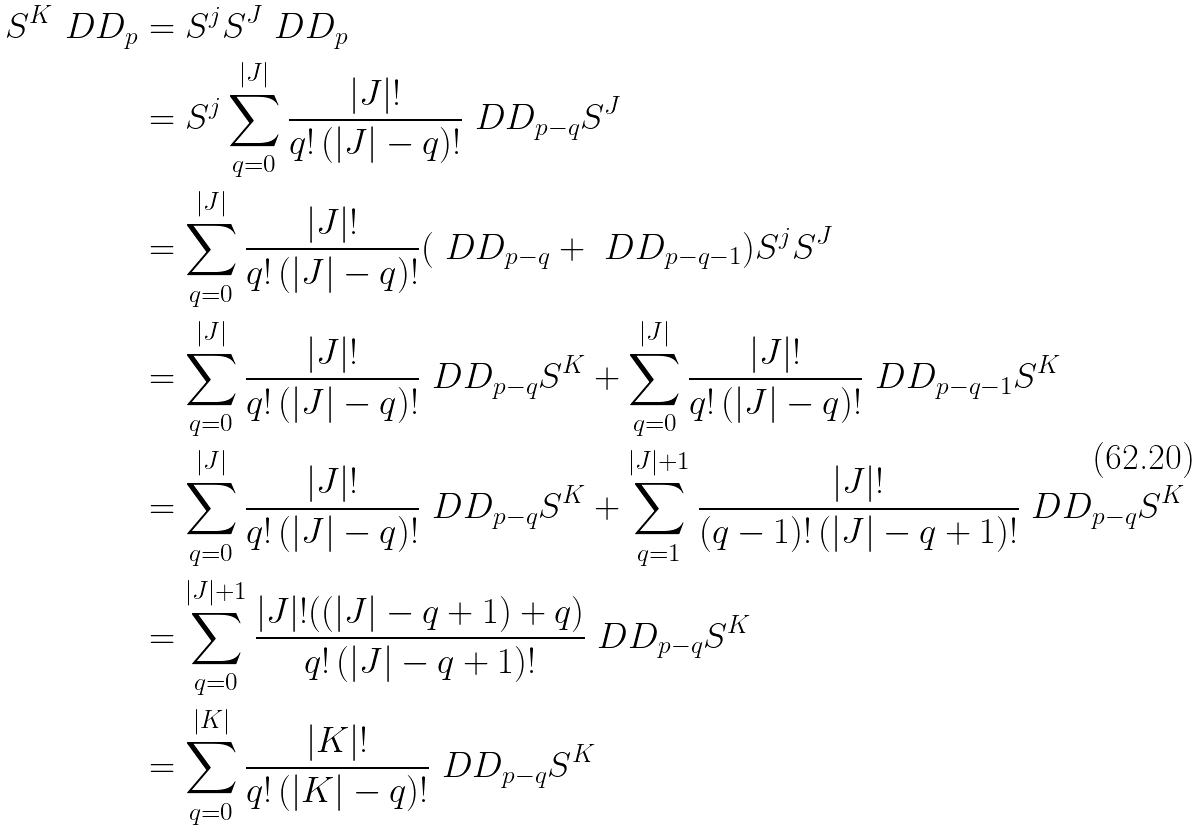Convert formula to latex. <formula><loc_0><loc_0><loc_500><loc_500>S ^ { K } \ D D _ { p } & = S ^ { j } S ^ { J } \ D D _ { p } \\ & = S ^ { j } \sum _ { q = 0 } ^ { | J | } \frac { | J | ! } { q ! \, ( | J | - q ) ! } \ D D _ { p - q } S ^ { J } \\ & = \sum _ { q = 0 } ^ { | J | } \frac { | J | ! } { q ! \, ( | J | - q ) ! } ( \ D D _ { p - q } + \ D D _ { p - q - 1 } ) S ^ { j } S ^ { J } \\ & = \sum _ { q = 0 } ^ { | J | } \frac { | J | ! } { q ! \, ( | J | - q ) ! } \ D D _ { p - q } S ^ { K } + \sum _ { q = 0 } ^ { | J | } \frac { | J | ! } { q ! \, ( | J | - q ) ! } \ D D _ { p - q - 1 } S ^ { K } \\ & = \sum _ { q = 0 } ^ { | J | } \frac { | J | ! } { q ! \, ( | J | - q ) ! } \ D D _ { p - q } S ^ { K } + \sum _ { q = 1 } ^ { | J | + 1 } \frac { | J | ! } { ( q - 1 ) ! \, ( | J | - q + 1 ) ! } \ D D _ { p - q } S ^ { K } \\ & = \sum _ { q = 0 } ^ { | J | + 1 } \frac { | J | ! ( ( | J | - q + 1 ) + q ) } { q ! \, ( | J | - q + 1 ) ! } \ D D _ { p - q } S ^ { K } \\ & = \sum _ { q = 0 } ^ { | K | } \frac { | K | ! } { q ! \, ( | K | - q ) ! } \ D D _ { p - q } S ^ { K }</formula> 